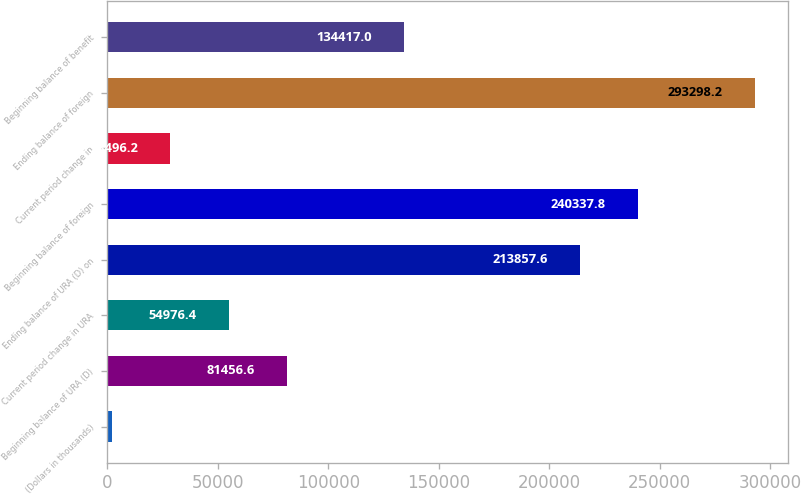Convert chart. <chart><loc_0><loc_0><loc_500><loc_500><bar_chart><fcel>(Dollars in thousands)<fcel>Beginning balance of URA (D)<fcel>Current period change in URA<fcel>Ending balance of URA (D) on<fcel>Beginning balance of foreign<fcel>Current period change in<fcel>Ending balance of foreign<fcel>Beginning balance of benefit<nl><fcel>2016<fcel>81456.6<fcel>54976.4<fcel>213858<fcel>240338<fcel>28496.2<fcel>293298<fcel>134417<nl></chart> 